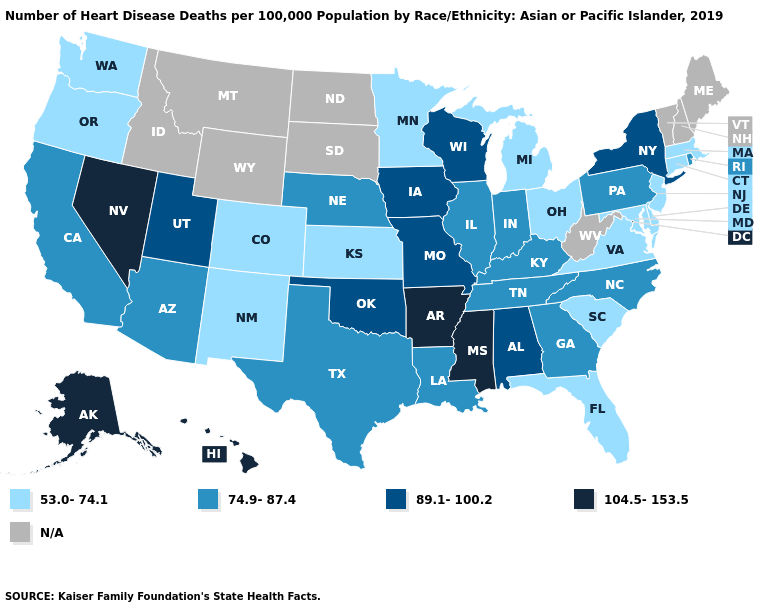Is the legend a continuous bar?
Write a very short answer. No. Does the map have missing data?
Answer briefly. Yes. Does Nevada have the highest value in the West?
Answer briefly. Yes. Does Georgia have the lowest value in the USA?
Give a very brief answer. No. Name the states that have a value in the range N/A?
Keep it brief. Idaho, Maine, Montana, New Hampshire, North Dakota, South Dakota, Vermont, West Virginia, Wyoming. What is the value of Arizona?
Be succinct. 74.9-87.4. What is the value of New Jersey?
Be succinct. 53.0-74.1. What is the lowest value in states that border Oregon?
Answer briefly. 53.0-74.1. Among the states that border Alabama , does Tennessee have the highest value?
Quick response, please. No. What is the value of Delaware?
Quick response, please. 53.0-74.1. Does California have the highest value in the West?
Keep it brief. No. Name the states that have a value in the range 104.5-153.5?
Concise answer only. Alaska, Arkansas, Hawaii, Mississippi, Nevada. What is the value of Virginia?
Quick response, please. 53.0-74.1. What is the value of Alaska?
Concise answer only. 104.5-153.5. 